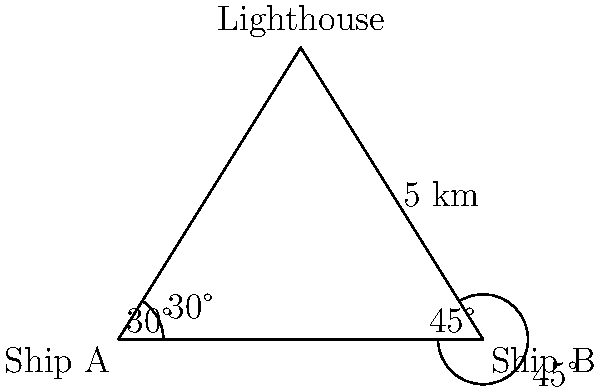As a product owner, you're developing an API for maritime navigation. To test its accuracy, you need to calculate the distance between two ships. Ship A is located 30° west of a lighthouse, while Ship B is 45° east of the same lighthouse. The distance between Ship B and the lighthouse is 5 km. Using this information, determine the distance between Ship A and Ship B to ensure the API provides correct calculations. Let's approach this step-by-step:

1) First, we can see that we have a triangle formed by Ship A, Ship B, and the lighthouse.

2) We know two angles of this triangle:
   - The angle at Ship A is 30°
   - The angle at Ship B is 45°

3) The sum of angles in a triangle is always 180°. So we can find the third angle:
   $180° - (30° + 45°) = 105°$

4) Now we have a triangle where we know all angles and one side (5 km from Ship B to the lighthouse).

5) To find the distance between Ship A and Ship B, we can use the sine law:

   $\frac{a}{\sin A} = \frac{b}{\sin B} = \frac{c}{\sin C}$

   Where $a$, $b$, and $c$ are the sides opposite to angles $A$, $B$, and $C$ respectively.

6) Let's call the distance we're looking for $x$. It's opposite to the 105° angle. So we can write:

   $\frac{x}{\sin 105°} = \frac{5}{\sin 30°}$

7) Solving for $x$:

   $x = \frac{5 \sin 105°}{\sin 30°}$

8) Using a calculator (or programming function in our API):

   $x \approx 8.19$ km

Therefore, the distance between Ship A and Ship B is approximately 8.19 km.
Answer: 8.19 km 